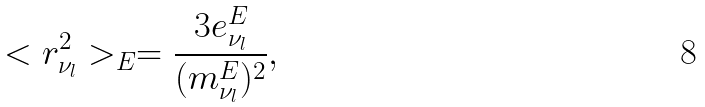Convert formula to latex. <formula><loc_0><loc_0><loc_500><loc_500>< r ^ { 2 } _ { \nu _ { l } } > _ { E } = \frac { 3 e _ { \nu _ { l } } ^ { E } } { ( m _ { \nu _ { l } } ^ { E } ) ^ { 2 } } ,</formula> 